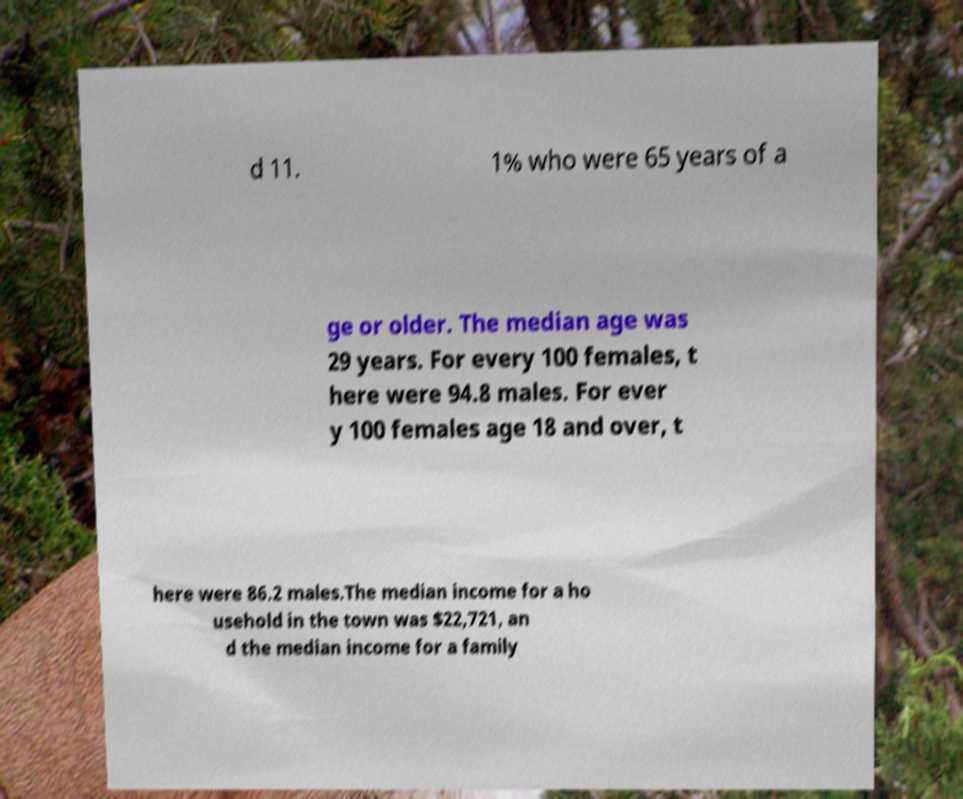For documentation purposes, I need the text within this image transcribed. Could you provide that? d 11. 1% who were 65 years of a ge or older. The median age was 29 years. For every 100 females, t here were 94.8 males. For ever y 100 females age 18 and over, t here were 86.2 males.The median income for a ho usehold in the town was $22,721, an d the median income for a family 